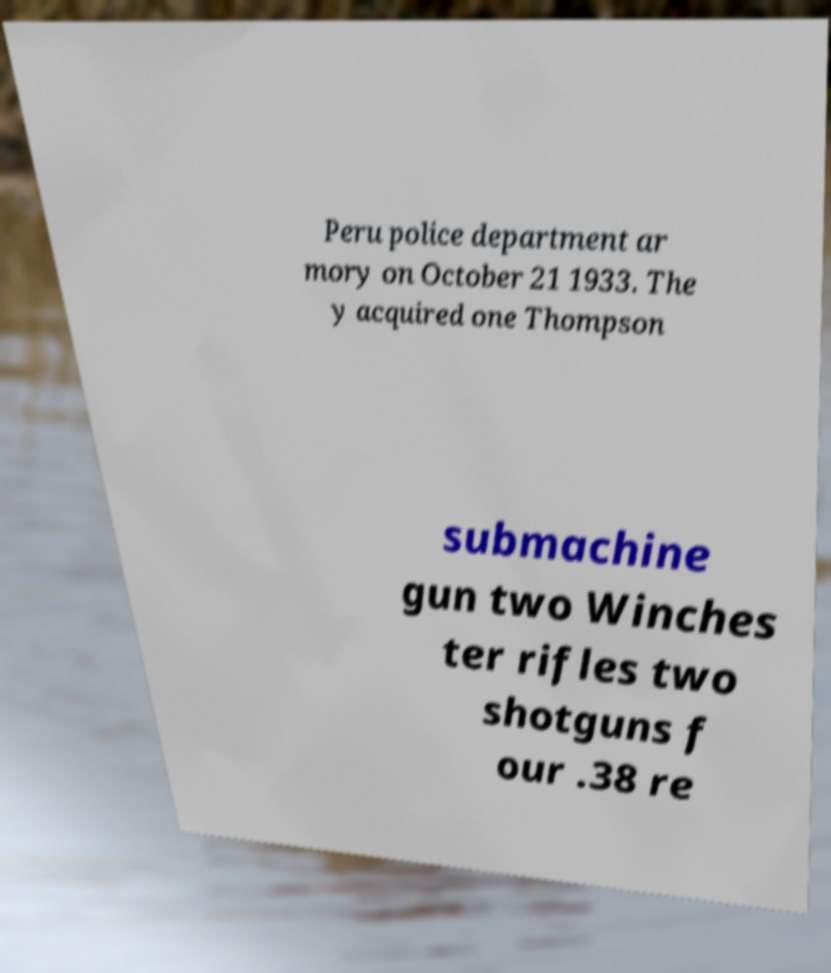Please read and relay the text visible in this image. What does it say? Peru police department ar mory on October 21 1933. The y acquired one Thompson submachine gun two Winches ter rifles two shotguns f our .38 re 